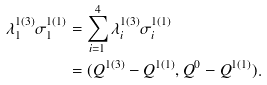Convert formula to latex. <formula><loc_0><loc_0><loc_500><loc_500>\lambda ^ { 1 ( 3 ) } _ { 1 } \sigma ^ { 1 ( 1 ) } _ { 1 } & = \sum _ { i = 1 } ^ { 4 } \lambda ^ { 1 ( 3 ) } _ { i } \sigma ^ { 1 ( 1 ) } _ { i } \\ & = ( Q ^ { 1 ( 3 ) } - Q ^ { 1 ( 1 ) } , Q ^ { 0 } - Q ^ { 1 ( 1 ) } ) .</formula> 